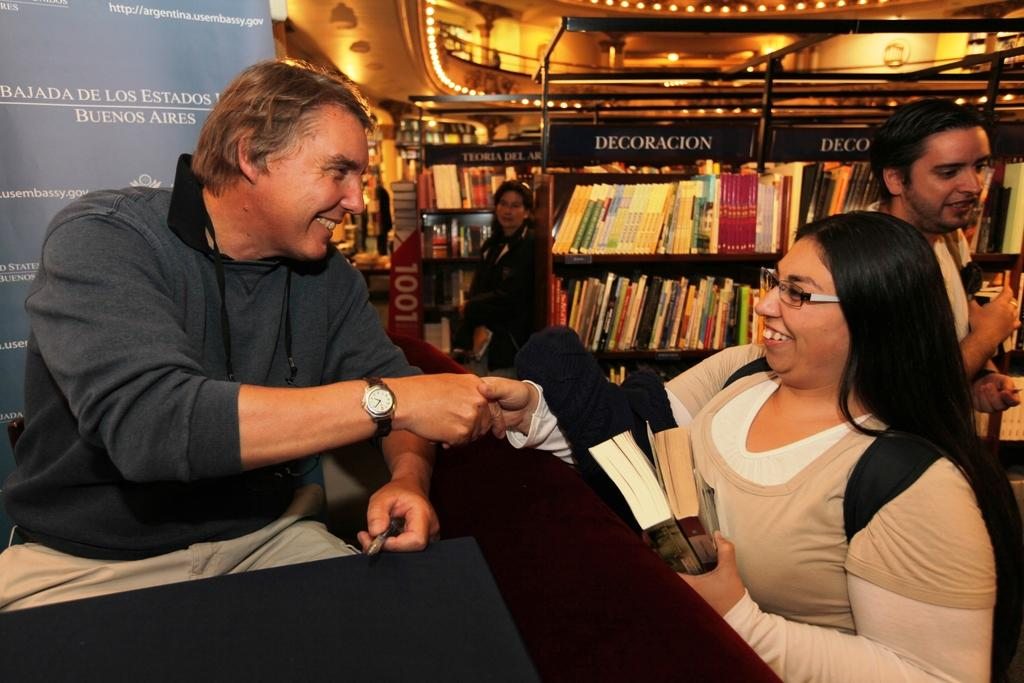How many people are in the group visible in the image? There is a group of people in the image, but the exact number is not specified. What can be seen in the background of the image? There are bookshelves, boards, and some objects visible in the background of the image. What might the boards be used for? The boards in the background could be used for various purposes, such as construction or display. How many birds are perched on the chin of the person in the image? There are no birds visible in the image, and no one's chin is mentioned. 